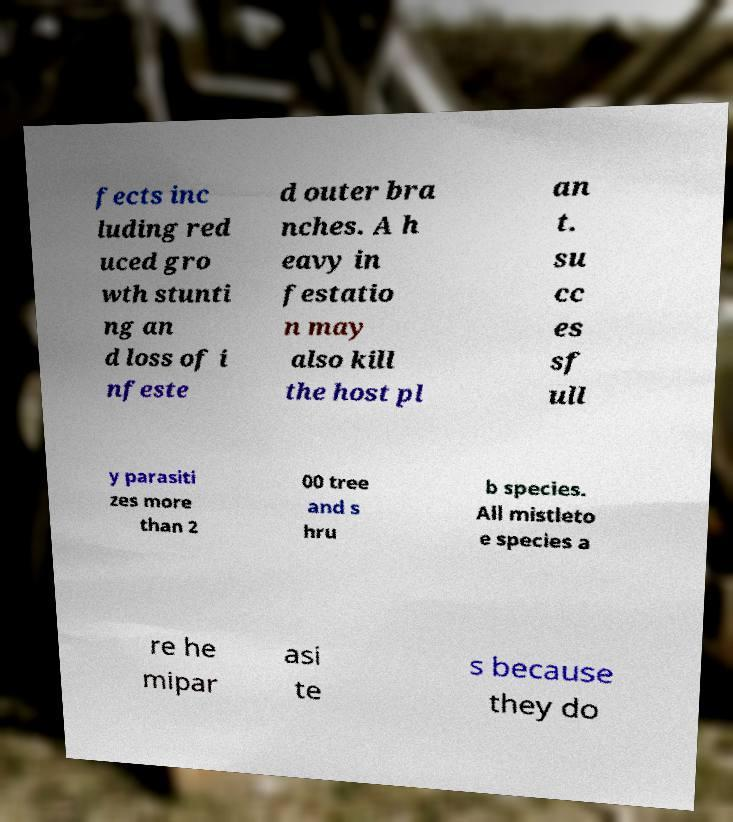What messages or text are displayed in this image? I need them in a readable, typed format. fects inc luding red uced gro wth stunti ng an d loss of i nfeste d outer bra nches. A h eavy in festatio n may also kill the host pl an t. su cc es sf ull y parasiti zes more than 2 00 tree and s hru b species. All mistleto e species a re he mipar asi te s because they do 